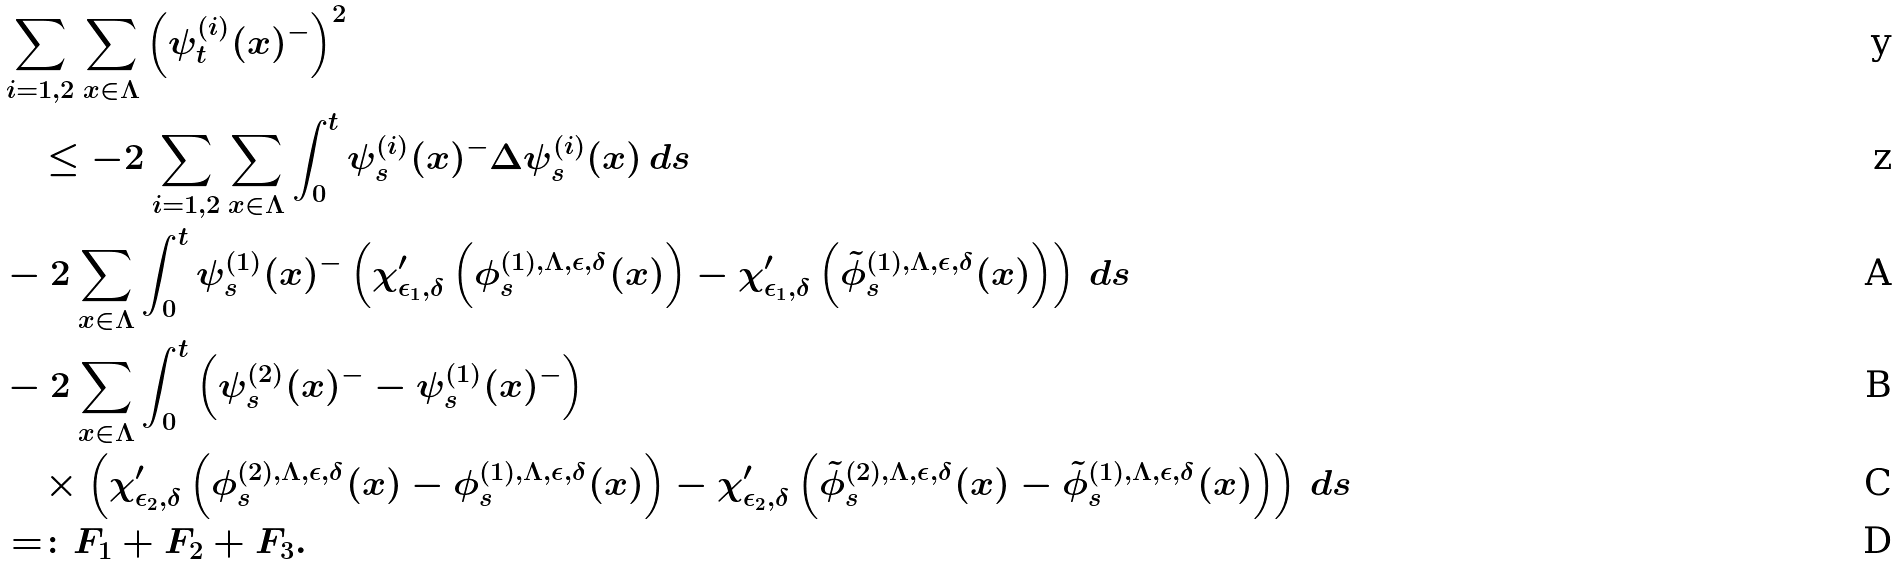Convert formula to latex. <formula><loc_0><loc_0><loc_500><loc_500>& \sum _ { i = 1 , 2 } \sum _ { x \in \Lambda } \left ( \psi ^ { ( i ) } _ { t } ( x ) ^ { - } \right ) ^ { 2 } \\ & \quad \leq - 2 \sum _ { i = 1 , 2 } \sum _ { x \in \Lambda } \int _ { 0 } ^ { t } \psi ^ { ( i ) } _ { s } ( x ) ^ { - } \Delta \psi ^ { ( i ) } _ { s } ( x ) \, d s \\ & - 2 \sum _ { x \in \Lambda } \int _ { 0 } ^ { t } \psi ^ { ( 1 ) } _ { s } ( x ) ^ { - } \left ( \chi ^ { \prime } _ { \epsilon _ { 1 } , \delta } \left ( \phi _ { s } ^ { ( 1 ) , \Lambda , \epsilon , \delta } ( x ) \right ) - \chi ^ { \prime } _ { \epsilon _ { 1 } , \delta } \left ( \tilde { \phi } _ { s } ^ { ( 1 ) , \Lambda , \epsilon , \delta } ( x ) \right ) \right ) \, d s \\ & - 2 \sum _ { x \in \Lambda } \int _ { 0 } ^ { t } \left ( \psi ^ { ( 2 ) } _ { s } ( x ) ^ { - } - \psi ^ { ( 1 ) } _ { s } ( x ) ^ { - } \right ) \\ & \quad \times \left ( \chi ^ { \prime } _ { \epsilon _ { 2 } , \delta } \left ( \phi _ { s } ^ { ( 2 ) , \Lambda , \epsilon , \delta } ( x ) - \phi _ { s } ^ { ( 1 ) , \Lambda , \epsilon , \delta } ( x ) \right ) - \chi ^ { \prime } _ { \epsilon _ { 2 } , \delta } \left ( \tilde { \phi } _ { s } ^ { ( 2 ) , \Lambda , \epsilon , \delta } ( x ) - \tilde { \phi } _ { s } ^ { ( 1 ) , \Lambda , \epsilon , \delta } ( x ) \right ) \right ) \, d s \\ & = \colon F _ { 1 } + F _ { 2 } + F _ { 3 } .</formula> 